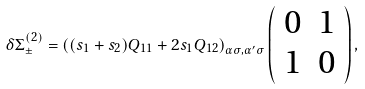Convert formula to latex. <formula><loc_0><loc_0><loc_500><loc_500>\delta { \Sigma } ^ { ( 2 ) } _ { \pm } = \left ( ( s _ { 1 } + s _ { 2 } ) Q _ { 1 1 } + 2 s _ { 1 } Q _ { 1 2 } \right ) _ { \alpha \sigma , \alpha ^ { \prime } \sigma } \left ( \begin{array} { c c } 0 & 1 \\ 1 & 0 \end{array} \right ) ,</formula> 